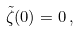Convert formula to latex. <formula><loc_0><loc_0><loc_500><loc_500>\tilde { \zeta } ( 0 ) = 0 \, ,</formula> 